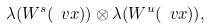Convert formula to latex. <formula><loc_0><loc_0><loc_500><loc_500>\lambda ( W ^ { s } ( \ v x ) ) \otimes \lambda ( W ^ { u } ( \ v x ) ) ,</formula> 